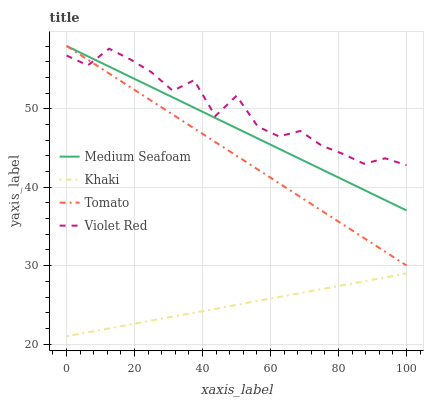Does Khaki have the minimum area under the curve?
Answer yes or no. Yes. Does Violet Red have the maximum area under the curve?
Answer yes or no. Yes. Does Violet Red have the minimum area under the curve?
Answer yes or no. No. Does Khaki have the maximum area under the curve?
Answer yes or no. No. Is Khaki the smoothest?
Answer yes or no. Yes. Is Violet Red the roughest?
Answer yes or no. Yes. Is Violet Red the smoothest?
Answer yes or no. No. Is Khaki the roughest?
Answer yes or no. No. Does Khaki have the lowest value?
Answer yes or no. Yes. Does Violet Red have the lowest value?
Answer yes or no. No. Does Medium Seafoam have the highest value?
Answer yes or no. Yes. Does Violet Red have the highest value?
Answer yes or no. No. Is Khaki less than Medium Seafoam?
Answer yes or no. Yes. Is Violet Red greater than Khaki?
Answer yes or no. Yes. Does Violet Red intersect Tomato?
Answer yes or no. Yes. Is Violet Red less than Tomato?
Answer yes or no. No. Is Violet Red greater than Tomato?
Answer yes or no. No. Does Khaki intersect Medium Seafoam?
Answer yes or no. No. 